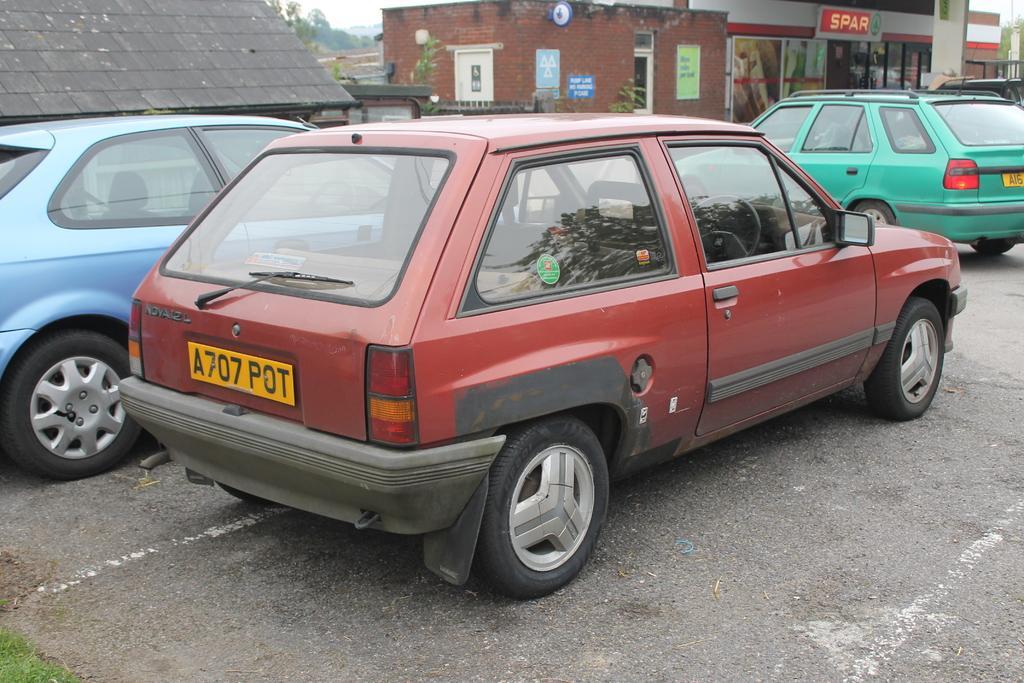In one or two sentences, can you explain what this image depicts? In the image there are few cars in the foreground, behind the cars there are some stores and in the background there are trees. 